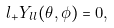<formula> <loc_0><loc_0><loc_500><loc_500>l _ { + } Y _ { l l } ( \theta , \phi ) = 0 ,</formula> 